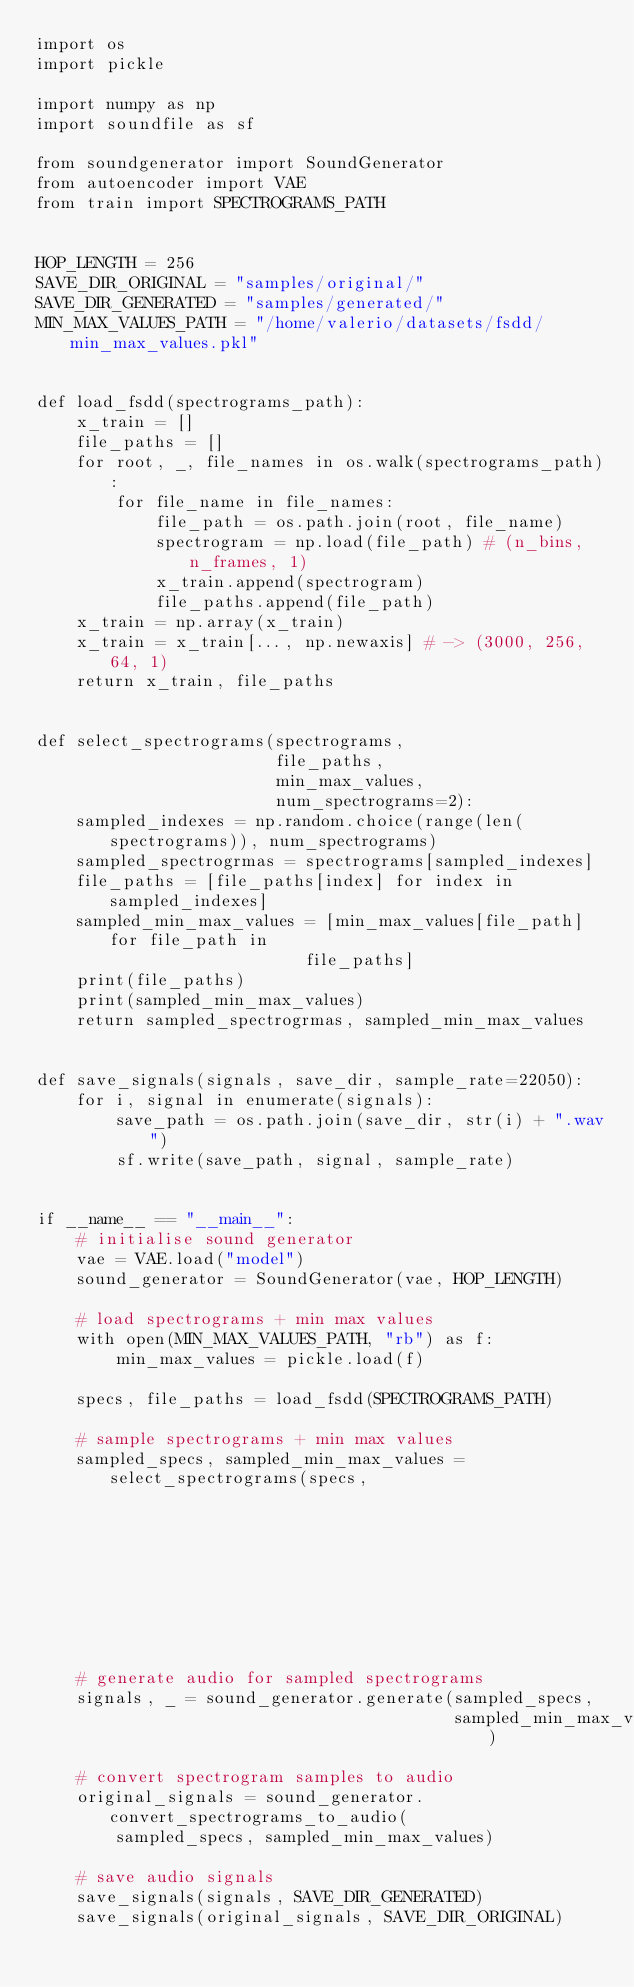<code> <loc_0><loc_0><loc_500><loc_500><_Python_>import os
import pickle

import numpy as np
import soundfile as sf

from soundgenerator import SoundGenerator
from autoencoder import VAE
from train import SPECTROGRAMS_PATH


HOP_LENGTH = 256
SAVE_DIR_ORIGINAL = "samples/original/"
SAVE_DIR_GENERATED = "samples/generated/"
MIN_MAX_VALUES_PATH = "/home/valerio/datasets/fsdd/min_max_values.pkl"


def load_fsdd(spectrograms_path):
    x_train = []
    file_paths = []
    for root, _, file_names in os.walk(spectrograms_path):
        for file_name in file_names:
            file_path = os.path.join(root, file_name)
            spectrogram = np.load(file_path) # (n_bins, n_frames, 1)
            x_train.append(spectrogram)
            file_paths.append(file_path)
    x_train = np.array(x_train)
    x_train = x_train[..., np.newaxis] # -> (3000, 256, 64, 1)
    return x_train, file_paths


def select_spectrograms(spectrograms,
                        file_paths,
                        min_max_values,
                        num_spectrograms=2):
    sampled_indexes = np.random.choice(range(len(spectrograms)), num_spectrograms)
    sampled_spectrogrmas = spectrograms[sampled_indexes]
    file_paths = [file_paths[index] for index in sampled_indexes]
    sampled_min_max_values = [min_max_values[file_path] for file_path in
                           file_paths]
    print(file_paths)
    print(sampled_min_max_values)
    return sampled_spectrogrmas, sampled_min_max_values


def save_signals(signals, save_dir, sample_rate=22050):
    for i, signal in enumerate(signals):
        save_path = os.path.join(save_dir, str(i) + ".wav")
        sf.write(save_path, signal, sample_rate)


if __name__ == "__main__":
    # initialise sound generator
    vae = VAE.load("model")
    sound_generator = SoundGenerator(vae, HOP_LENGTH)

    # load spectrograms + min max values
    with open(MIN_MAX_VALUES_PATH, "rb") as f:
        min_max_values = pickle.load(f)

    specs, file_paths = load_fsdd(SPECTROGRAMS_PATH)

    # sample spectrograms + min max values
    sampled_specs, sampled_min_max_values = select_spectrograms(specs,
                                                                file_paths,
                                                                min_max_values,
                                                                5)

    # generate audio for sampled spectrograms
    signals, _ = sound_generator.generate(sampled_specs,
                                          sampled_min_max_values)

    # convert spectrogram samples to audio
    original_signals = sound_generator.convert_spectrograms_to_audio(
        sampled_specs, sampled_min_max_values)

    # save audio signals
    save_signals(signals, SAVE_DIR_GENERATED)
    save_signals(original_signals, SAVE_DIR_ORIGINAL)






</code> 